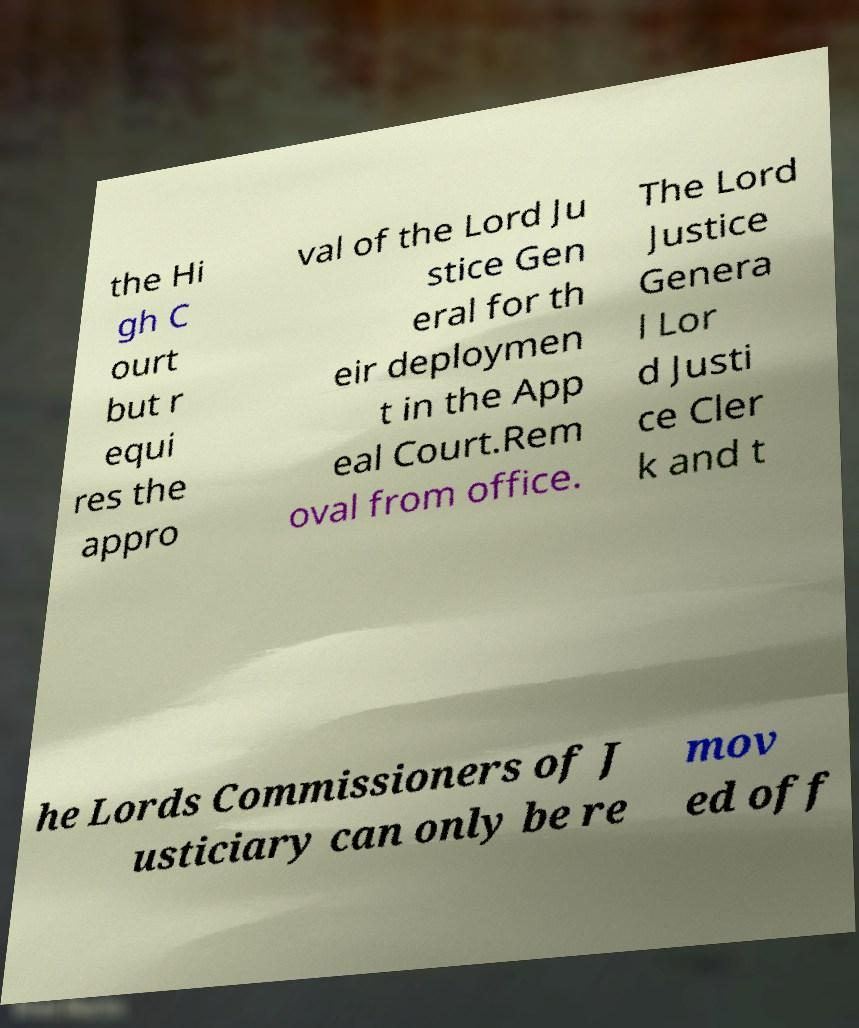Can you accurately transcribe the text from the provided image for me? the Hi gh C ourt but r equi res the appro val of the Lord Ju stice Gen eral for th eir deploymen t in the App eal Court.Rem oval from office. The Lord Justice Genera l Lor d Justi ce Cler k and t he Lords Commissioners of J usticiary can only be re mov ed off 